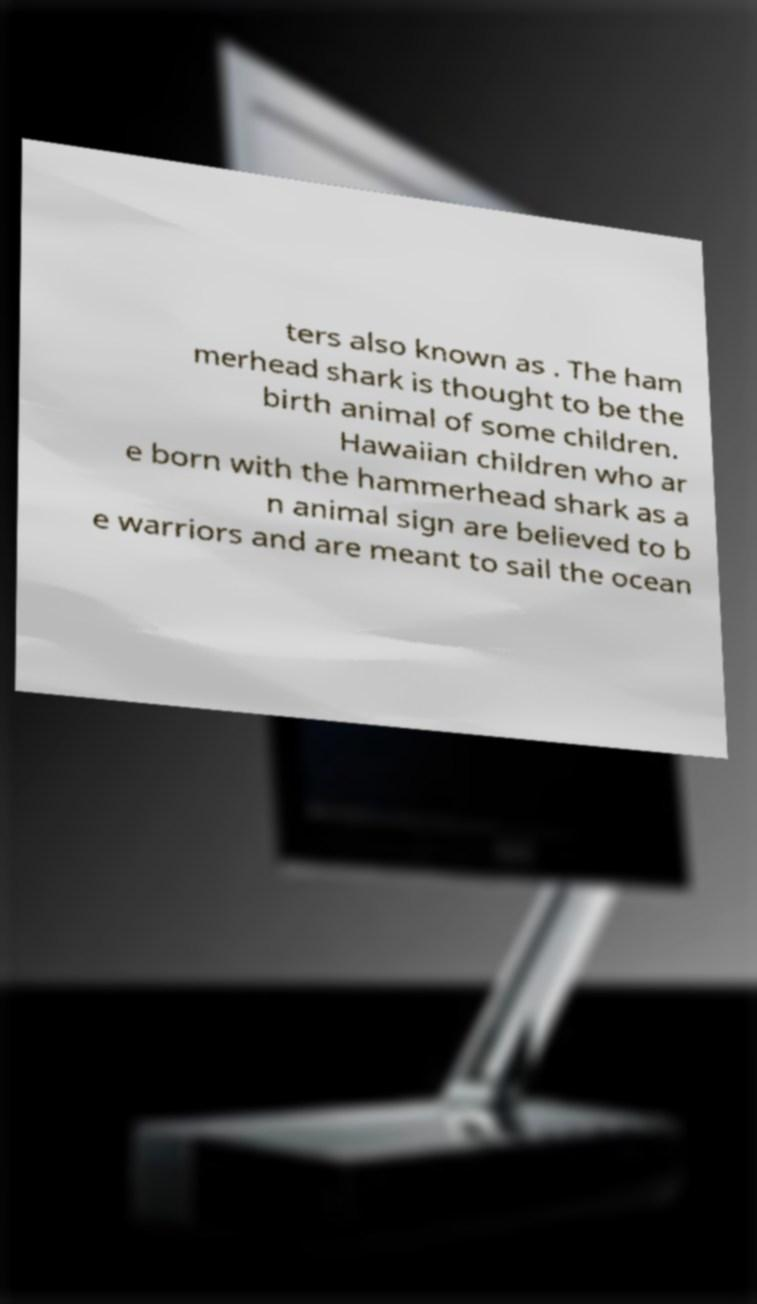There's text embedded in this image that I need extracted. Can you transcribe it verbatim? ters also known as . The ham merhead shark is thought to be the birth animal of some children. Hawaiian children who ar e born with the hammerhead shark as a n animal sign are believed to b e warriors and are meant to sail the ocean 